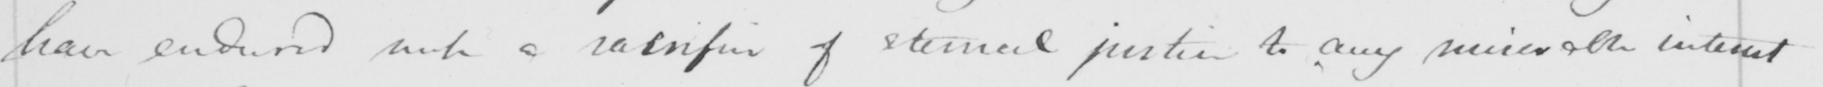Can you tell me what this handwritten text says? have endured such a sacrifice of eternal justice to any miserable interest 